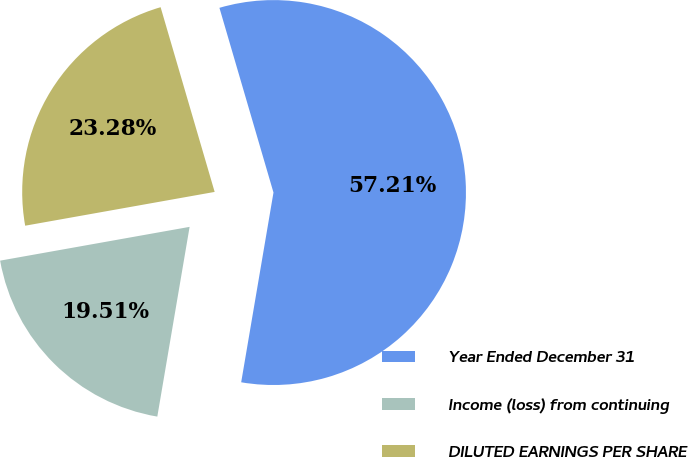<chart> <loc_0><loc_0><loc_500><loc_500><pie_chart><fcel>Year Ended December 31<fcel>Income (loss) from continuing<fcel>DILUTED EARNINGS PER SHARE<nl><fcel>57.22%<fcel>19.51%<fcel>23.28%<nl></chart> 